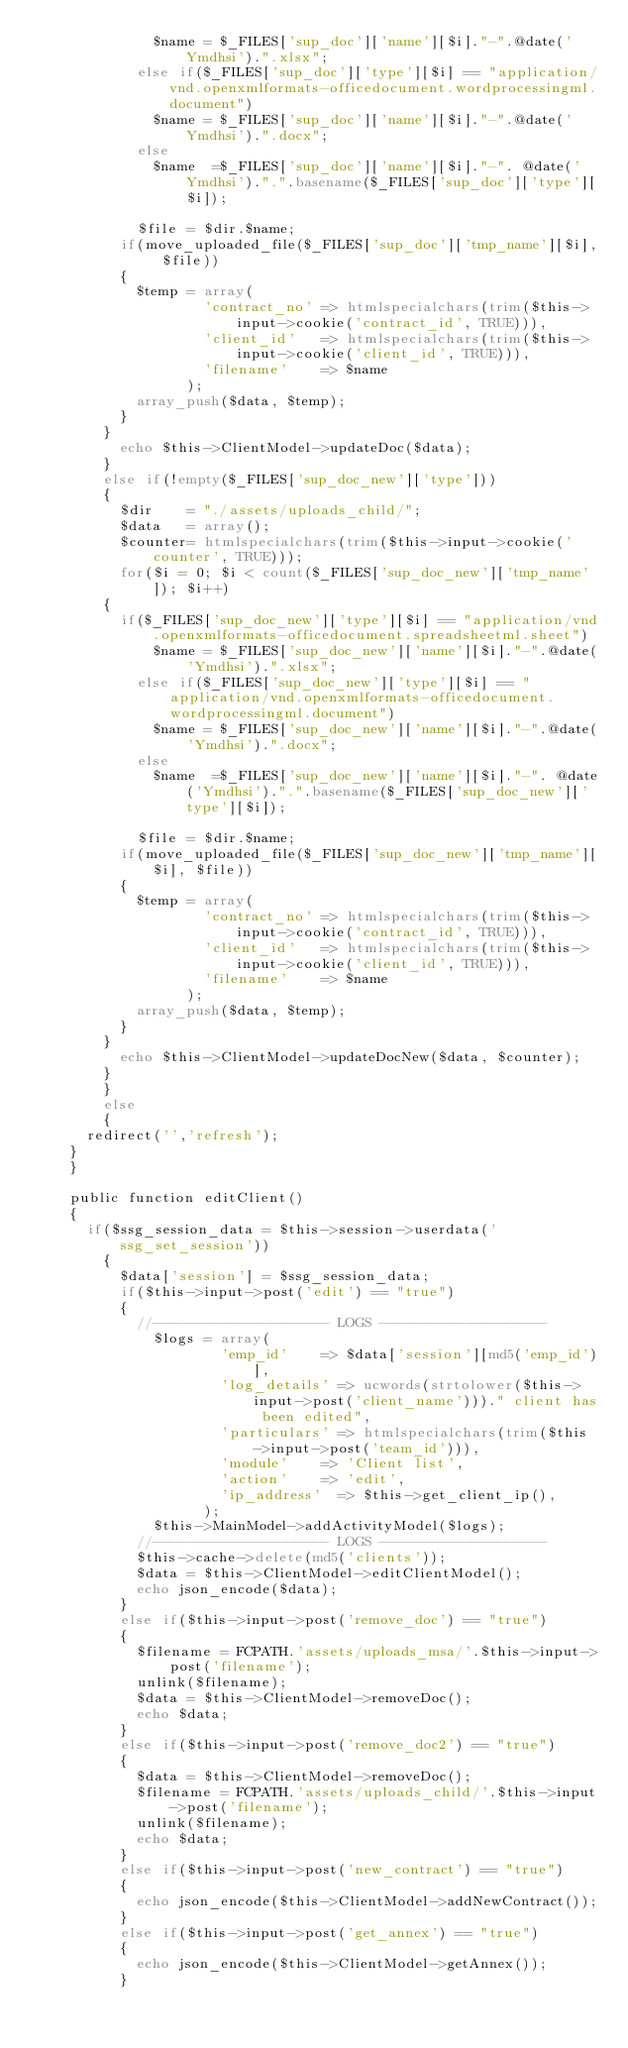<code> <loc_0><loc_0><loc_500><loc_500><_PHP_>		    			$name = $_FILES['sup_doc']['name'][$i]."-".@date('Ymdhsi').".xlsx";
		    		else if($_FILES['sup_doc']['type'][$i] == "application/vnd.openxmlformats-officedocument.wordprocessingml.document")
		    			$name = $_FILES['sup_doc']['name'][$i]."-".@date('Ymdhsi').".docx";
		    		else
		    			$name  =$_FILES['sup_doc']['name'][$i]."-". @date('Ymdhsi').".".basename($_FILES['sup_doc']['type'][$i]);

		    		$file = $dir.$name;
					if(move_uploaded_file($_FILES['sup_doc']['tmp_name'][$i], $file))
					{
						$temp = array(
										'contract_no' => htmlspecialchars(trim($this->input->cookie('contract_id', TRUE))),
										'client_id'	  => htmlspecialchars(trim($this->input->cookie('client_id', TRUE))),
										'filename'	  => $name
									);
						array_push($data, $temp);
					}
				}
    			echo $this->ClientModel->updateDoc($data);
    		}
    		else if(!empty($_FILES['sup_doc_new']['type']))
	    	{
	    		$dir   	= "./assets/uploads_child/";
	    		$data  	= array();
	    		$counter= htmlspecialchars(trim($this->input->cookie('counter', TRUE)));
	    		for($i = 0; $i < count($_FILES['sup_doc_new']['tmp_name']); $i++)
				{
					if($_FILES['sup_doc_new']['type'][$i] == "application/vnd.openxmlformats-officedocument.spreadsheetml.sheet")
		    			$name = $_FILES['sup_doc_new']['name'][$i]."-".@date('Ymdhsi').".xlsx";
		    		else if($_FILES['sup_doc_new']['type'][$i] == "application/vnd.openxmlformats-officedocument.wordprocessingml.document")
		    			$name = $_FILES['sup_doc_new']['name'][$i]."-".@date('Ymdhsi').".docx";
		    		else
		    			$name  =$_FILES['sup_doc_new']['name'][$i]."-". @date('Ymdhsi').".".basename($_FILES['sup_doc_new']['type'][$i]);

		    		$file = $dir.$name;
					if(move_uploaded_file($_FILES['sup_doc_new']['tmp_name'][$i], $file))
					{
						$temp = array(
										'contract_no' => htmlspecialchars(trim($this->input->cookie('contract_id', TRUE))),
										'client_id'	  => htmlspecialchars(trim($this->input->cookie('client_id', TRUE))),
										'filename'	  => $name
									);
						array_push($data, $temp);
					}
				}
    			echo $this->ClientModel->updateDocNew($data, $counter);
    		}
        }
        else
        {
			redirect('','refresh');
		}
    }

  	public function editClient()
    {
    	if($ssg_session_data = $this->session->userdata('ssg_set_session'))
        {
        	$data['session'] = $ssg_session_data;
	        if($this->input->post('edit') == "true")
	        {
	        	//--------------------- LOGS --------------------
		        	$logs = array(
		        					'emp_id' 		=> $data['session'][md5('emp_id')],
		        					'log_details'	=> ucwords(strtolower($this->input->post('client_name')))." client has been edited",
		        					'particulars'	=> htmlspecialchars(trim($this->input->post('team_id'))),
		        					'module'		=> 'Client list',
		        					'action'		=> 'edit',
		        					'ip_address'	=> $this->get_client_ip(),
		        				);
		        	$this->MainModel->addActivityModel($logs);
		        //--------------------- LOGS --------------------
        		$this->cache->delete(md5('clients'));
	        	$data = $this->ClientModel->editClientModel();
	        	echo json_encode($data);
	        }
	        else if($this->input->post('remove_doc') == "true")
	        {
	        	$filename = FCPATH.'assets/uploads_msa/'.$this->input->post('filename');
	        	unlink($filename);
	        	$data = $this->ClientModel->removeDoc();
	        	echo $data;
	        }
	        else if($this->input->post('remove_doc2') == "true")
	        {
	        	$data = $this->ClientModel->removeDoc();
	        	$filename = FCPATH.'assets/uploads_child/'.$this->input->post('filename');
	        	unlink($filename);
	        	echo $data;
	        }
	        else if($this->input->post('new_contract') == "true")
	        {
	        	echo json_encode($this->ClientModel->addNewContract());
	        }
	        else if($this->input->post('get_annex') == "true")
	        {
	        	echo json_encode($this->ClientModel->getAnnex());
	        }</code> 